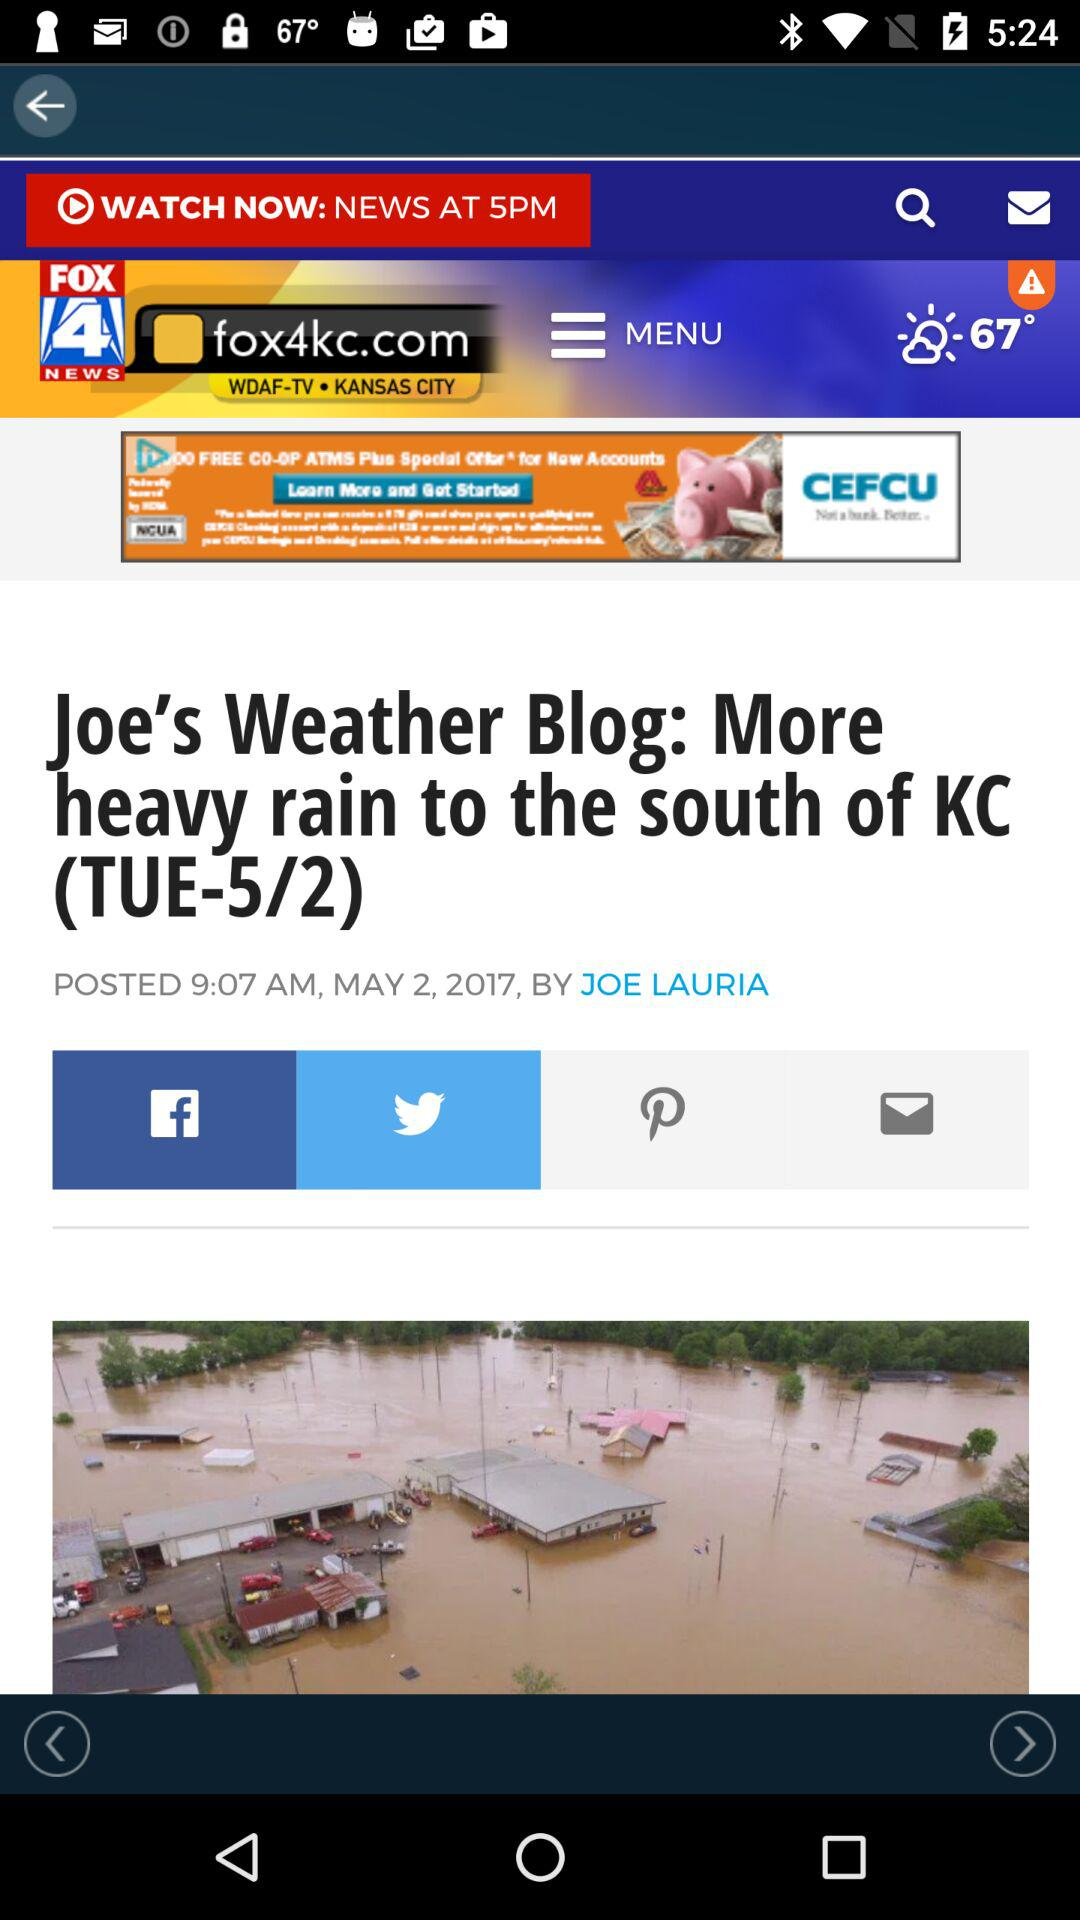At what time was the news posted? The news was posted at 9:07 AM. 